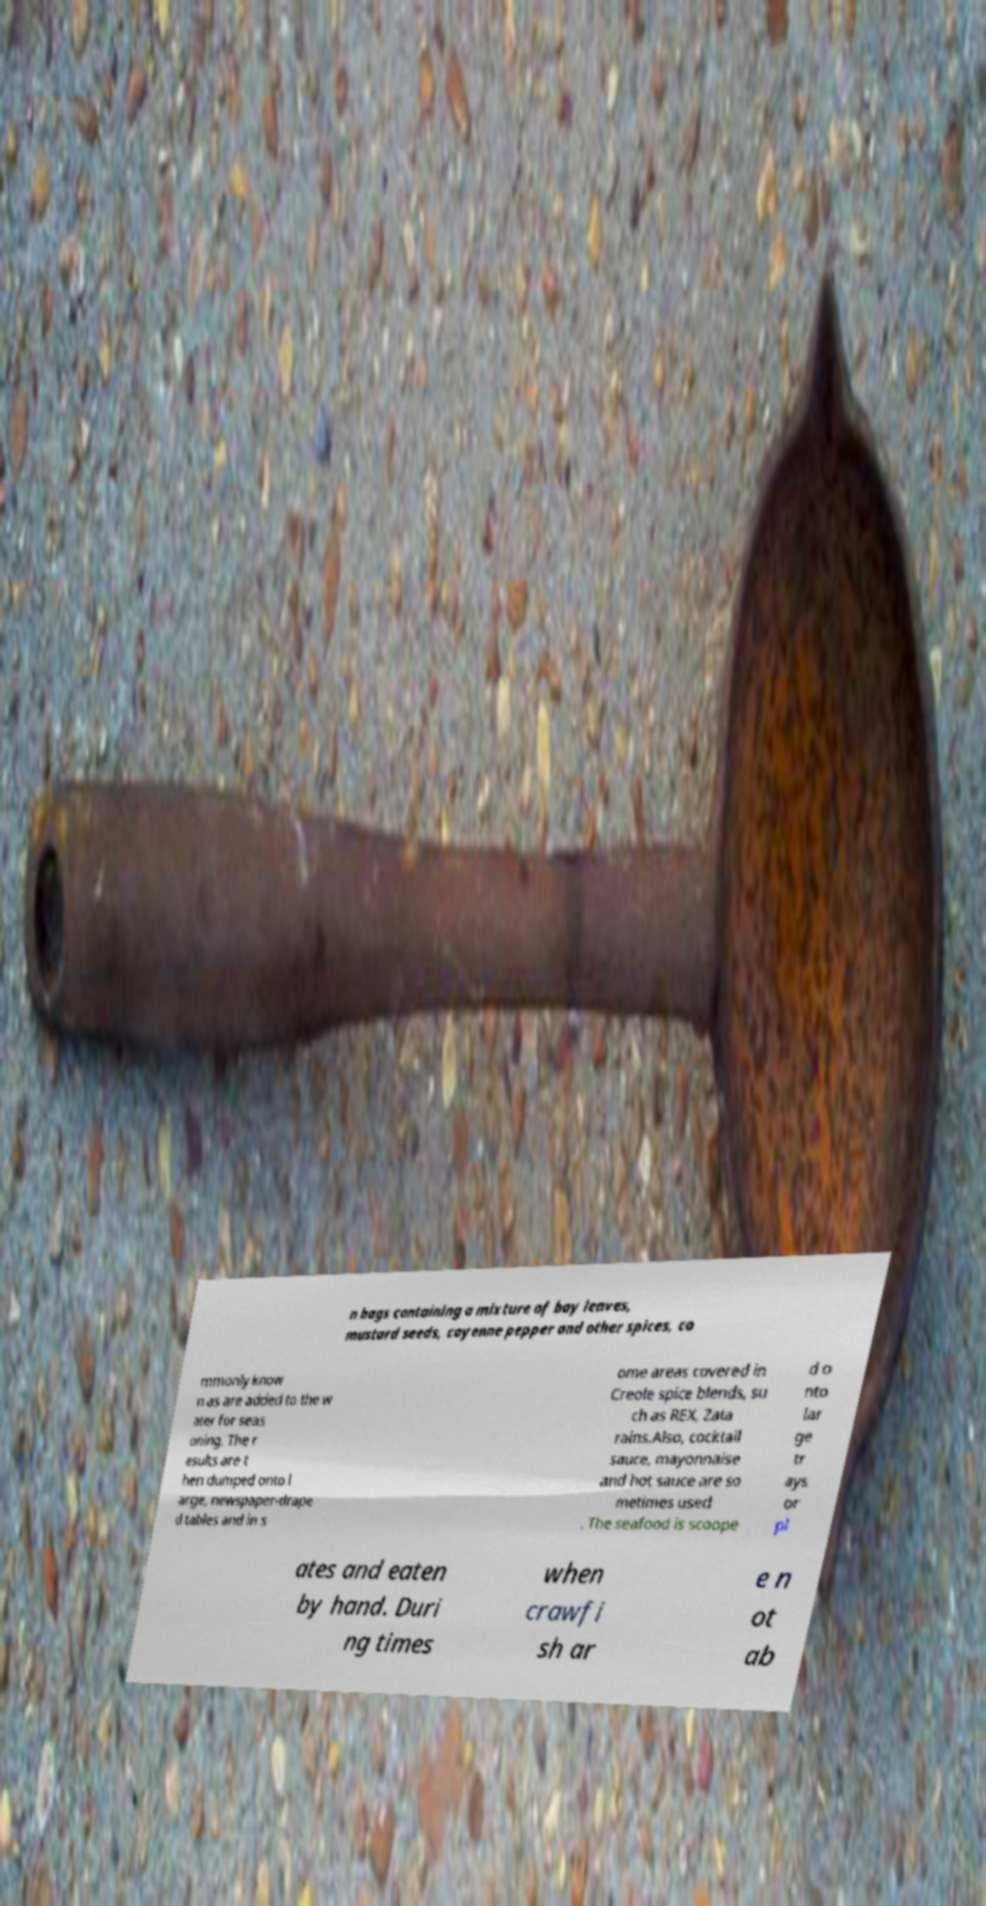Could you extract and type out the text from this image? n bags containing a mixture of bay leaves, mustard seeds, cayenne pepper and other spices, co mmonly know n as are added to the w ater for seas oning. The r esults are t hen dumped onto l arge, newspaper-drape d tables and in s ome areas covered in Creole spice blends, su ch as REX, Zata rains.Also, cocktail sauce, mayonnaise and hot sauce are so metimes used . The seafood is scoope d o nto lar ge tr ays or pl ates and eaten by hand. Duri ng times when crawfi sh ar e n ot ab 